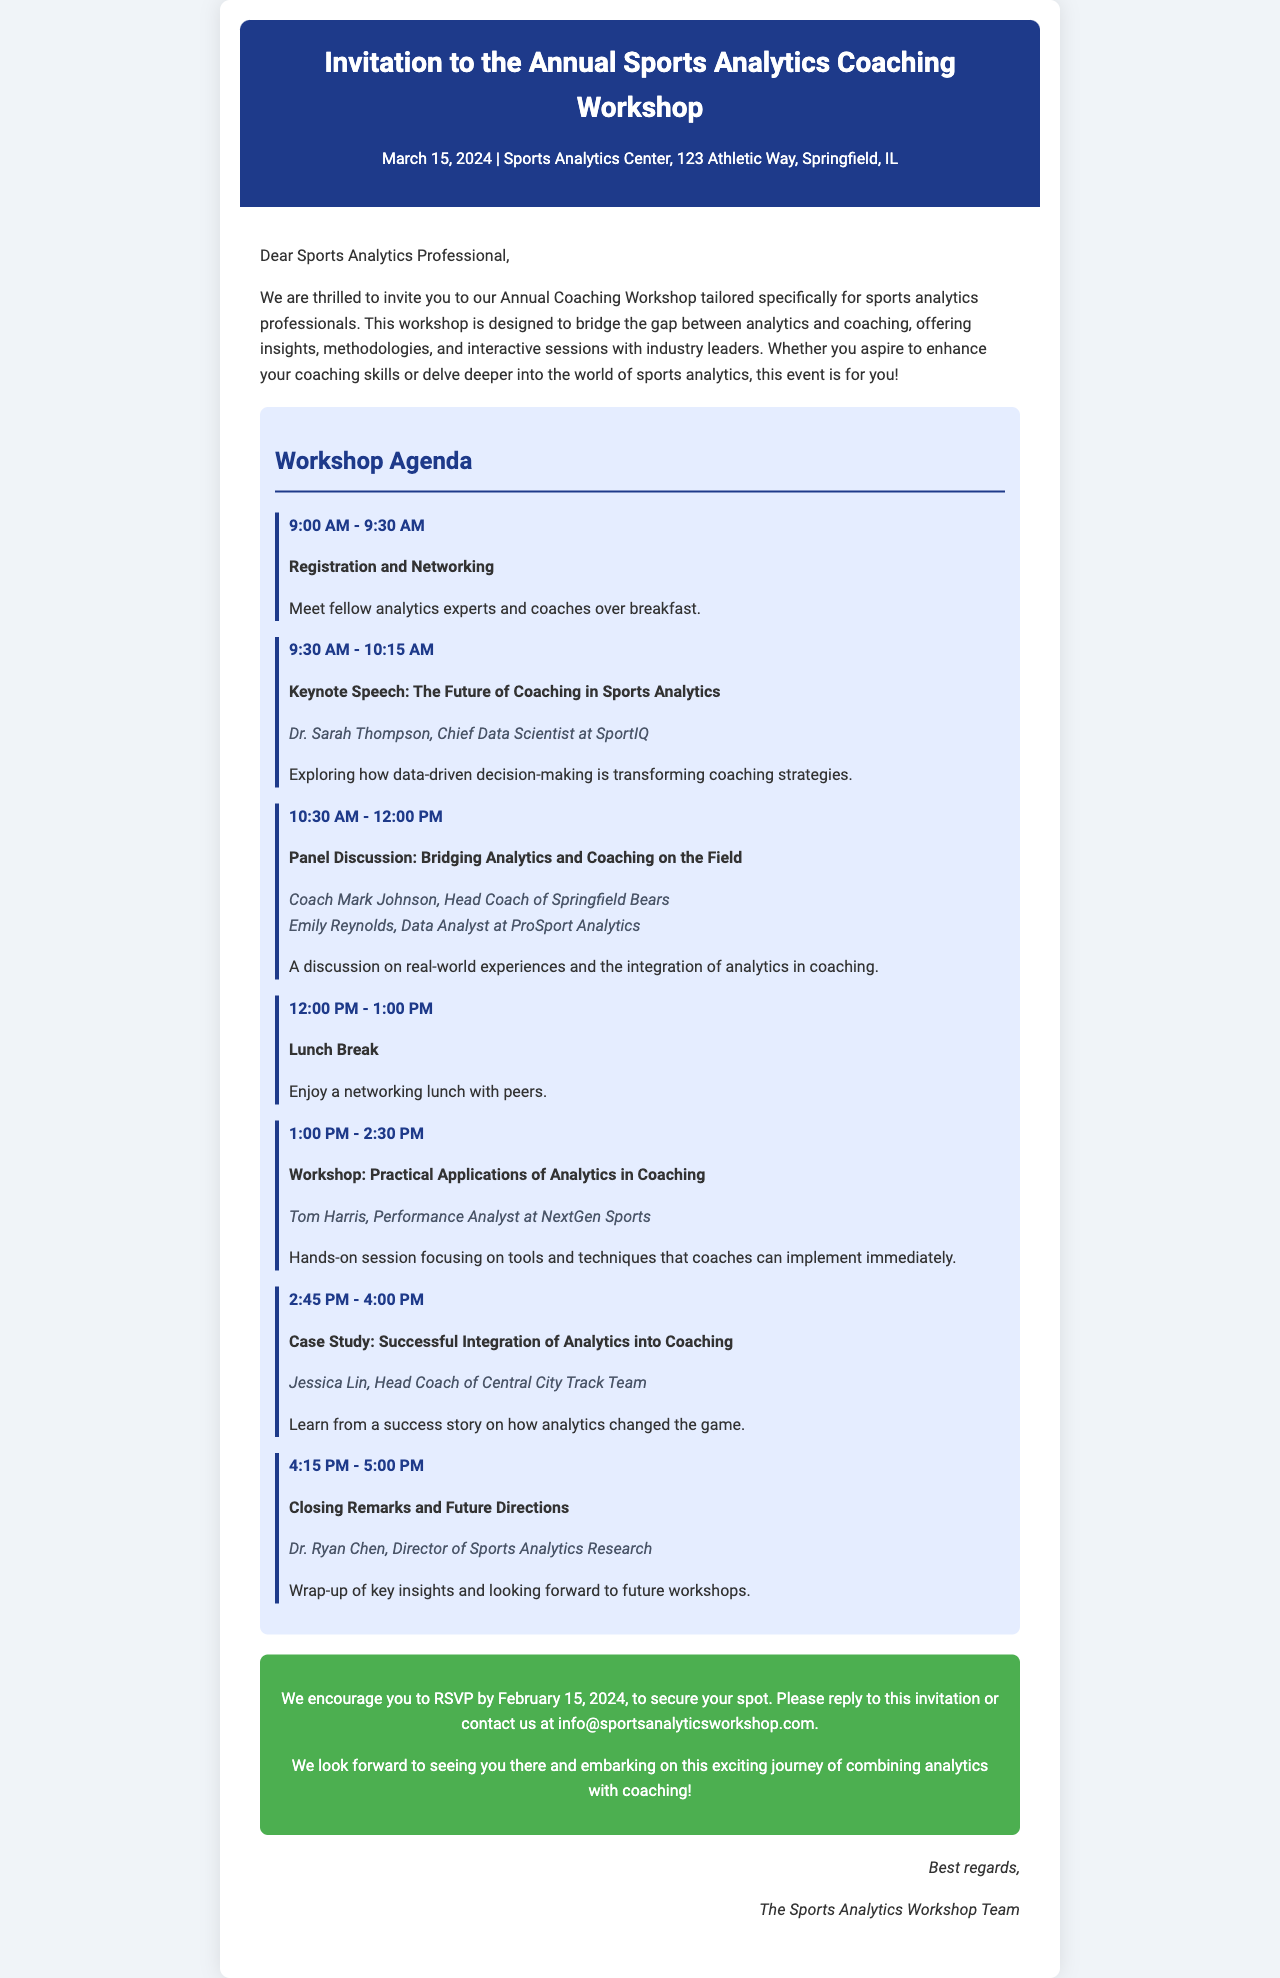What is the date of the workshop? The date of the workshop is specifically mentioned in the document as March 15, 2024.
Answer: March 15, 2024 Who is the keynote speaker? The document highlights Dr. Sarah Thompson as the keynote speaker during the session on the future of coaching.
Answer: Dr. Sarah Thompson What location is the workshop being held? The document states that the workshop is held at the Sports Analytics Center, 123 Athletic Way, Springfield, IL.
Answer: Sports Analytics Center, 123 Athletic Way, Springfield, IL What time does registration start? The agenda indicates registration begins at 9:00 AM.
Answer: 9:00 AM How long is the lunch break? The agenda specifies a one-hour duration for the lunch break, from 12:00 PM to 1:00 PM.
Answer: 1 hour Which session focuses on practical applications of analytics? The session titled "Workshop: Practical Applications of Analytics in Coaching" specifically addresses practical applications.
Answer: Workshop: Practical Applications of Analytics in Coaching When is the RSVP deadline? The RSVP deadline is clearly stated in the document as February 15, 2024.
Answer: February 15, 2024 Who will give closing remarks? The document lists Dr. Ryan Chen as the individual providing closing remarks at the end of the workshop.
Answer: Dr. Ryan Chen What is the primary goal of the workshop? The essential goal of the workshop is to bridge the gap between analytics and coaching, as mentioned in the invitation.
Answer: Bridge the gap between analytics and coaching 